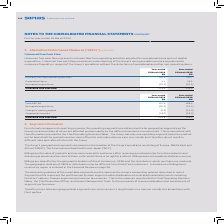According to Sophos Group's financial document, What does unlevered free cash flow represent? net cash flow from operating activities adjusted for exceptional items and net capital expenditure. The document states: "Unlevered free cash flow represents net cash flow from operating activities adjusted for exceptional items and net capital expenditure. Unlevered free..." Also, What does unlevered free cash flow provide? an understanding of the Group’s cash generation and is a supplemental measure of liquidity in respect of the Group’s operations without the distortions of exceptional and other non-operating items. The document states: "al expenditure. Unlevered free cash flow provides an understanding of the Group’s cash generation and is a supplemental measure of liquidity in respec..." Also, What are the components in the table used to calculate the unlevered free cash flow? The document contains multiple relevant values: Net cash flow from operating activities, Exceptional items, Net capital expenditure. From the document: "Exceptional items 3.1 13.0 Net cash flow from operating activities 142.9 147.7 Net capital expenditure (22.2) (21.1)..." Additionally, In which year was the amount of Net cash flow from operating activities larger? According to the financial document, 2018. The relevant text states: "Year-ended 31 March 2018 $M..." Also, can you calculate: What was the change in exceptional items in 2019 from 2018? Based on the calculation: 3.1-13.0, the result is -9.9 (in millions). This is based on the information: "Exceptional items 3.1 13.0 Exceptional items 3.1 13.0..." The key data points involved are: 13.0, 3.1. Also, can you calculate: What was the percentage change in exceptional items in 2019 from 2018? To answer this question, I need to perform calculations using the financial data. The calculation is: (3.1-13.0)/13.0, which equals -76.15 (percentage). This is based on the information: "Exceptional items 3.1 13.0 Exceptional items 3.1 13.0..." The key data points involved are: 13.0, 3.1. 